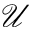<formula> <loc_0><loc_0><loc_500><loc_500>\mathcal { U }</formula> 